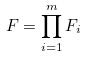Convert formula to latex. <formula><loc_0><loc_0><loc_500><loc_500>F = \prod _ { i = 1 } ^ { m } F _ { i }</formula> 